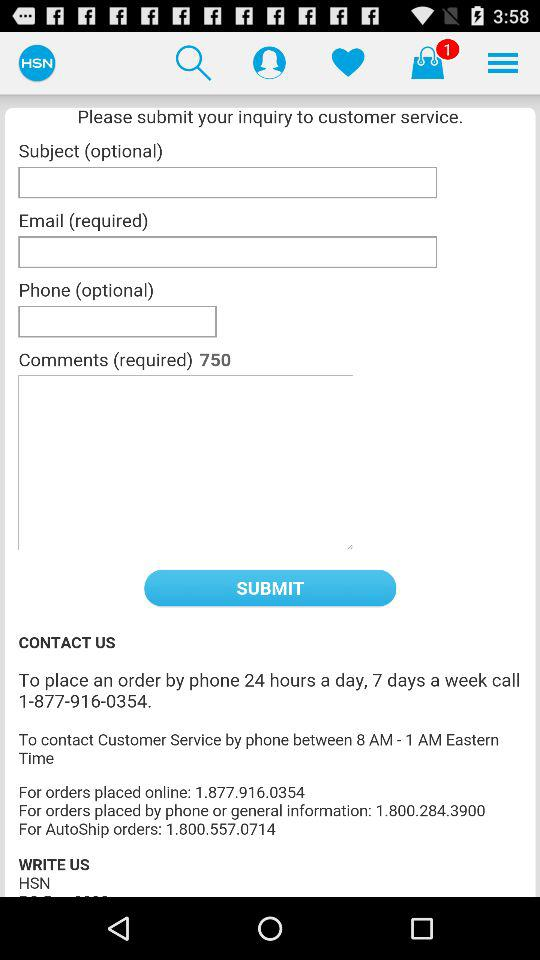What is the time to contact customer service by phone? The time to contact customer service by phone is between 8 a.m. and 1 a.m. Eastern Time. 